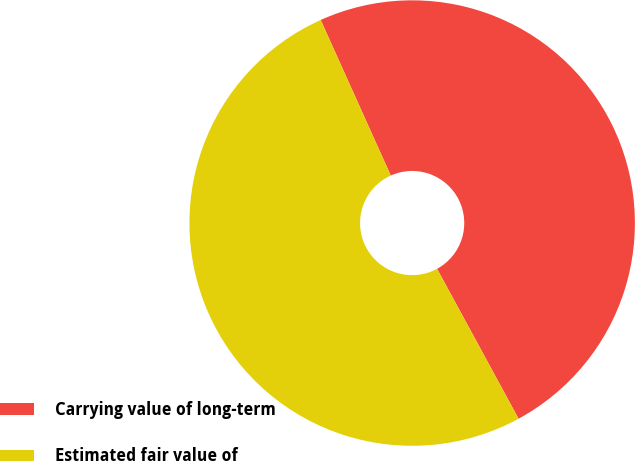Convert chart to OTSL. <chart><loc_0><loc_0><loc_500><loc_500><pie_chart><fcel>Carrying value of long-term<fcel>Estimated fair value of<nl><fcel>48.81%<fcel>51.19%<nl></chart> 